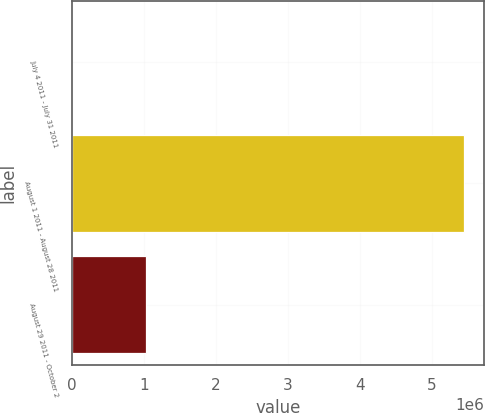<chart> <loc_0><loc_0><loc_500><loc_500><bar_chart><fcel>July 4 2011 - July 31 2011<fcel>August 1 2011 - August 28 2011<fcel>August 29 2011 - October 2<nl><fcel>1.32<fcel>5.4546e+06<fcel>1.0286e+06<nl></chart> 